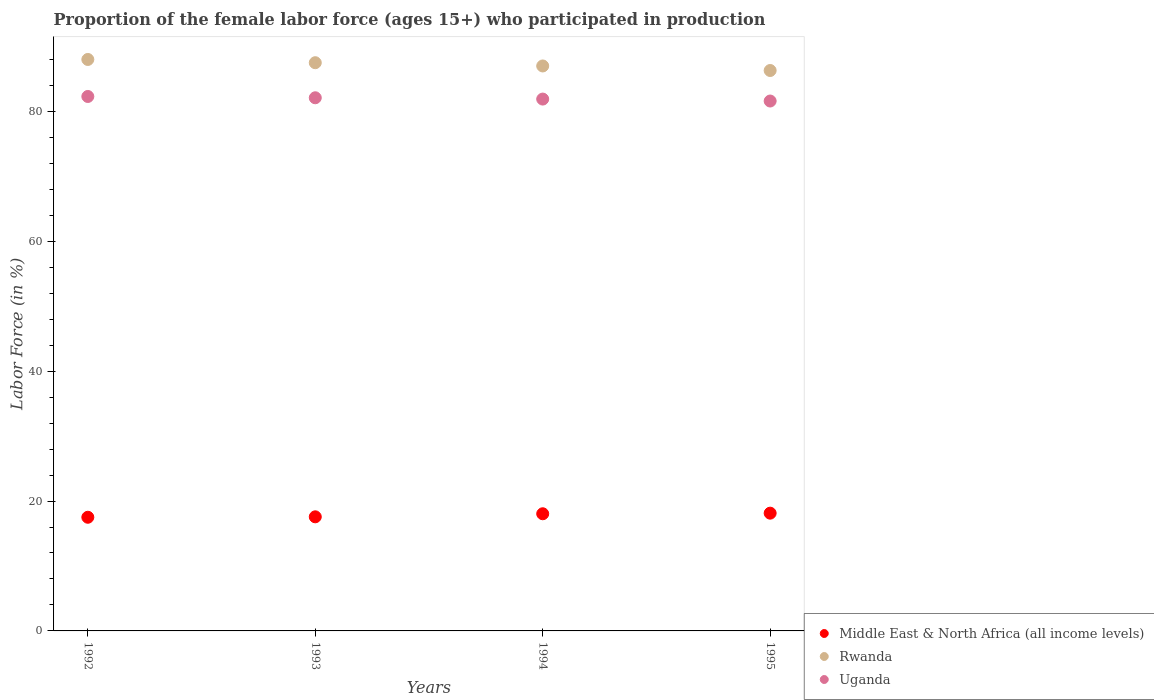How many different coloured dotlines are there?
Ensure brevity in your answer.  3. What is the proportion of the female labor force who participated in production in Rwanda in 1992?
Offer a very short reply. 88. Across all years, what is the maximum proportion of the female labor force who participated in production in Rwanda?
Provide a short and direct response. 88. Across all years, what is the minimum proportion of the female labor force who participated in production in Uganda?
Offer a very short reply. 81.6. In which year was the proportion of the female labor force who participated in production in Rwanda minimum?
Give a very brief answer. 1995. What is the total proportion of the female labor force who participated in production in Middle East & North Africa (all income levels) in the graph?
Offer a terse response. 71.25. What is the difference between the proportion of the female labor force who participated in production in Middle East & North Africa (all income levels) in 1993 and that in 1995?
Your answer should be compact. -0.56. What is the difference between the proportion of the female labor force who participated in production in Rwanda in 1994 and the proportion of the female labor force who participated in production in Uganda in 1995?
Make the answer very short. 5.4. What is the average proportion of the female labor force who participated in production in Rwanda per year?
Your response must be concise. 87.2. In the year 1992, what is the difference between the proportion of the female labor force who participated in production in Uganda and proportion of the female labor force who participated in production in Rwanda?
Provide a succinct answer. -5.7. What is the ratio of the proportion of the female labor force who participated in production in Uganda in 1992 to that in 1993?
Give a very brief answer. 1. What is the difference between the highest and the second highest proportion of the female labor force who participated in production in Middle East & North Africa (all income levels)?
Offer a terse response. 0.09. What is the difference between the highest and the lowest proportion of the female labor force who participated in production in Middle East & North Africa (all income levels)?
Offer a terse response. 0.63. In how many years, is the proportion of the female labor force who participated in production in Uganda greater than the average proportion of the female labor force who participated in production in Uganda taken over all years?
Make the answer very short. 2. Is the sum of the proportion of the female labor force who participated in production in Uganda in 1993 and 1994 greater than the maximum proportion of the female labor force who participated in production in Middle East & North Africa (all income levels) across all years?
Give a very brief answer. Yes. Does the proportion of the female labor force who participated in production in Middle East & North Africa (all income levels) monotonically increase over the years?
Offer a terse response. Yes. What is the difference between two consecutive major ticks on the Y-axis?
Offer a terse response. 20. Does the graph contain grids?
Offer a very short reply. No. Where does the legend appear in the graph?
Ensure brevity in your answer.  Bottom right. How many legend labels are there?
Ensure brevity in your answer.  3. What is the title of the graph?
Offer a terse response. Proportion of the female labor force (ages 15+) who participated in production. Does "Iran" appear as one of the legend labels in the graph?
Offer a terse response. No. What is the label or title of the Y-axis?
Offer a terse response. Labor Force (in %). What is the Labor Force (in %) of Middle East & North Africa (all income levels) in 1992?
Your answer should be very brief. 17.5. What is the Labor Force (in %) in Rwanda in 1992?
Keep it short and to the point. 88. What is the Labor Force (in %) in Uganda in 1992?
Provide a succinct answer. 82.3. What is the Labor Force (in %) in Middle East & North Africa (all income levels) in 1993?
Your answer should be compact. 17.57. What is the Labor Force (in %) of Rwanda in 1993?
Provide a short and direct response. 87.5. What is the Labor Force (in %) in Uganda in 1993?
Your answer should be very brief. 82.1. What is the Labor Force (in %) of Middle East & North Africa (all income levels) in 1994?
Your answer should be very brief. 18.04. What is the Labor Force (in %) of Uganda in 1994?
Make the answer very short. 81.9. What is the Labor Force (in %) of Middle East & North Africa (all income levels) in 1995?
Provide a succinct answer. 18.13. What is the Labor Force (in %) of Rwanda in 1995?
Make the answer very short. 86.3. What is the Labor Force (in %) in Uganda in 1995?
Provide a short and direct response. 81.6. Across all years, what is the maximum Labor Force (in %) of Middle East & North Africa (all income levels)?
Provide a succinct answer. 18.13. Across all years, what is the maximum Labor Force (in %) of Rwanda?
Give a very brief answer. 88. Across all years, what is the maximum Labor Force (in %) in Uganda?
Give a very brief answer. 82.3. Across all years, what is the minimum Labor Force (in %) of Middle East & North Africa (all income levels)?
Make the answer very short. 17.5. Across all years, what is the minimum Labor Force (in %) in Rwanda?
Your answer should be compact. 86.3. Across all years, what is the minimum Labor Force (in %) in Uganda?
Your answer should be very brief. 81.6. What is the total Labor Force (in %) in Middle East & North Africa (all income levels) in the graph?
Your answer should be very brief. 71.25. What is the total Labor Force (in %) in Rwanda in the graph?
Your answer should be compact. 348.8. What is the total Labor Force (in %) of Uganda in the graph?
Offer a very short reply. 327.9. What is the difference between the Labor Force (in %) of Middle East & North Africa (all income levels) in 1992 and that in 1993?
Your response must be concise. -0.07. What is the difference between the Labor Force (in %) in Uganda in 1992 and that in 1993?
Make the answer very short. 0.2. What is the difference between the Labor Force (in %) of Middle East & North Africa (all income levels) in 1992 and that in 1994?
Your answer should be very brief. -0.54. What is the difference between the Labor Force (in %) in Uganda in 1992 and that in 1994?
Make the answer very short. 0.4. What is the difference between the Labor Force (in %) in Middle East & North Africa (all income levels) in 1992 and that in 1995?
Provide a succinct answer. -0.63. What is the difference between the Labor Force (in %) of Uganda in 1992 and that in 1995?
Make the answer very short. 0.7. What is the difference between the Labor Force (in %) of Middle East & North Africa (all income levels) in 1993 and that in 1994?
Keep it short and to the point. -0.47. What is the difference between the Labor Force (in %) in Rwanda in 1993 and that in 1994?
Offer a terse response. 0.5. What is the difference between the Labor Force (in %) in Uganda in 1993 and that in 1994?
Your response must be concise. 0.2. What is the difference between the Labor Force (in %) of Middle East & North Africa (all income levels) in 1993 and that in 1995?
Provide a short and direct response. -0.56. What is the difference between the Labor Force (in %) in Middle East & North Africa (all income levels) in 1994 and that in 1995?
Make the answer very short. -0.09. What is the difference between the Labor Force (in %) in Rwanda in 1994 and that in 1995?
Your answer should be very brief. 0.7. What is the difference between the Labor Force (in %) in Middle East & North Africa (all income levels) in 1992 and the Labor Force (in %) in Rwanda in 1993?
Provide a succinct answer. -70. What is the difference between the Labor Force (in %) in Middle East & North Africa (all income levels) in 1992 and the Labor Force (in %) in Uganda in 1993?
Offer a very short reply. -64.6. What is the difference between the Labor Force (in %) of Rwanda in 1992 and the Labor Force (in %) of Uganda in 1993?
Provide a short and direct response. 5.9. What is the difference between the Labor Force (in %) in Middle East & North Africa (all income levels) in 1992 and the Labor Force (in %) in Rwanda in 1994?
Give a very brief answer. -69.5. What is the difference between the Labor Force (in %) of Middle East & North Africa (all income levels) in 1992 and the Labor Force (in %) of Uganda in 1994?
Your answer should be compact. -64.4. What is the difference between the Labor Force (in %) of Rwanda in 1992 and the Labor Force (in %) of Uganda in 1994?
Ensure brevity in your answer.  6.1. What is the difference between the Labor Force (in %) of Middle East & North Africa (all income levels) in 1992 and the Labor Force (in %) of Rwanda in 1995?
Make the answer very short. -68.8. What is the difference between the Labor Force (in %) in Middle East & North Africa (all income levels) in 1992 and the Labor Force (in %) in Uganda in 1995?
Ensure brevity in your answer.  -64.1. What is the difference between the Labor Force (in %) of Middle East & North Africa (all income levels) in 1993 and the Labor Force (in %) of Rwanda in 1994?
Provide a short and direct response. -69.43. What is the difference between the Labor Force (in %) of Middle East & North Africa (all income levels) in 1993 and the Labor Force (in %) of Uganda in 1994?
Your answer should be very brief. -64.33. What is the difference between the Labor Force (in %) in Rwanda in 1993 and the Labor Force (in %) in Uganda in 1994?
Offer a terse response. 5.6. What is the difference between the Labor Force (in %) in Middle East & North Africa (all income levels) in 1993 and the Labor Force (in %) in Rwanda in 1995?
Offer a very short reply. -68.73. What is the difference between the Labor Force (in %) of Middle East & North Africa (all income levels) in 1993 and the Labor Force (in %) of Uganda in 1995?
Your answer should be compact. -64.03. What is the difference between the Labor Force (in %) of Rwanda in 1993 and the Labor Force (in %) of Uganda in 1995?
Ensure brevity in your answer.  5.9. What is the difference between the Labor Force (in %) in Middle East & North Africa (all income levels) in 1994 and the Labor Force (in %) in Rwanda in 1995?
Offer a terse response. -68.26. What is the difference between the Labor Force (in %) in Middle East & North Africa (all income levels) in 1994 and the Labor Force (in %) in Uganda in 1995?
Keep it short and to the point. -63.56. What is the difference between the Labor Force (in %) of Rwanda in 1994 and the Labor Force (in %) of Uganda in 1995?
Give a very brief answer. 5.4. What is the average Labor Force (in %) of Middle East & North Africa (all income levels) per year?
Your answer should be compact. 17.81. What is the average Labor Force (in %) of Rwanda per year?
Offer a very short reply. 87.2. What is the average Labor Force (in %) in Uganda per year?
Keep it short and to the point. 81.97. In the year 1992, what is the difference between the Labor Force (in %) of Middle East & North Africa (all income levels) and Labor Force (in %) of Rwanda?
Ensure brevity in your answer.  -70.5. In the year 1992, what is the difference between the Labor Force (in %) in Middle East & North Africa (all income levels) and Labor Force (in %) in Uganda?
Offer a terse response. -64.8. In the year 1993, what is the difference between the Labor Force (in %) of Middle East & North Africa (all income levels) and Labor Force (in %) of Rwanda?
Offer a very short reply. -69.93. In the year 1993, what is the difference between the Labor Force (in %) in Middle East & North Africa (all income levels) and Labor Force (in %) in Uganda?
Give a very brief answer. -64.53. In the year 1994, what is the difference between the Labor Force (in %) in Middle East & North Africa (all income levels) and Labor Force (in %) in Rwanda?
Ensure brevity in your answer.  -68.96. In the year 1994, what is the difference between the Labor Force (in %) of Middle East & North Africa (all income levels) and Labor Force (in %) of Uganda?
Provide a succinct answer. -63.86. In the year 1995, what is the difference between the Labor Force (in %) of Middle East & North Africa (all income levels) and Labor Force (in %) of Rwanda?
Give a very brief answer. -68.17. In the year 1995, what is the difference between the Labor Force (in %) in Middle East & North Africa (all income levels) and Labor Force (in %) in Uganda?
Offer a terse response. -63.47. In the year 1995, what is the difference between the Labor Force (in %) in Rwanda and Labor Force (in %) in Uganda?
Your answer should be very brief. 4.7. What is the ratio of the Labor Force (in %) in Rwanda in 1992 to that in 1993?
Ensure brevity in your answer.  1.01. What is the ratio of the Labor Force (in %) in Uganda in 1992 to that in 1993?
Provide a short and direct response. 1. What is the ratio of the Labor Force (in %) in Middle East & North Africa (all income levels) in 1992 to that in 1994?
Offer a very short reply. 0.97. What is the ratio of the Labor Force (in %) in Rwanda in 1992 to that in 1994?
Provide a short and direct response. 1.01. What is the ratio of the Labor Force (in %) of Uganda in 1992 to that in 1994?
Your response must be concise. 1. What is the ratio of the Labor Force (in %) of Middle East & North Africa (all income levels) in 1992 to that in 1995?
Provide a succinct answer. 0.97. What is the ratio of the Labor Force (in %) of Rwanda in 1992 to that in 1995?
Give a very brief answer. 1.02. What is the ratio of the Labor Force (in %) of Uganda in 1992 to that in 1995?
Offer a very short reply. 1.01. What is the ratio of the Labor Force (in %) in Middle East & North Africa (all income levels) in 1993 to that in 1994?
Provide a succinct answer. 0.97. What is the ratio of the Labor Force (in %) of Uganda in 1993 to that in 1994?
Your answer should be compact. 1. What is the ratio of the Labor Force (in %) of Rwanda in 1993 to that in 1995?
Your answer should be compact. 1.01. What is the ratio of the Labor Force (in %) in Uganda in 1994 to that in 1995?
Provide a short and direct response. 1. What is the difference between the highest and the second highest Labor Force (in %) of Middle East & North Africa (all income levels)?
Your response must be concise. 0.09. What is the difference between the highest and the second highest Labor Force (in %) of Uganda?
Your response must be concise. 0.2. What is the difference between the highest and the lowest Labor Force (in %) in Middle East & North Africa (all income levels)?
Give a very brief answer. 0.63. What is the difference between the highest and the lowest Labor Force (in %) of Uganda?
Provide a succinct answer. 0.7. 